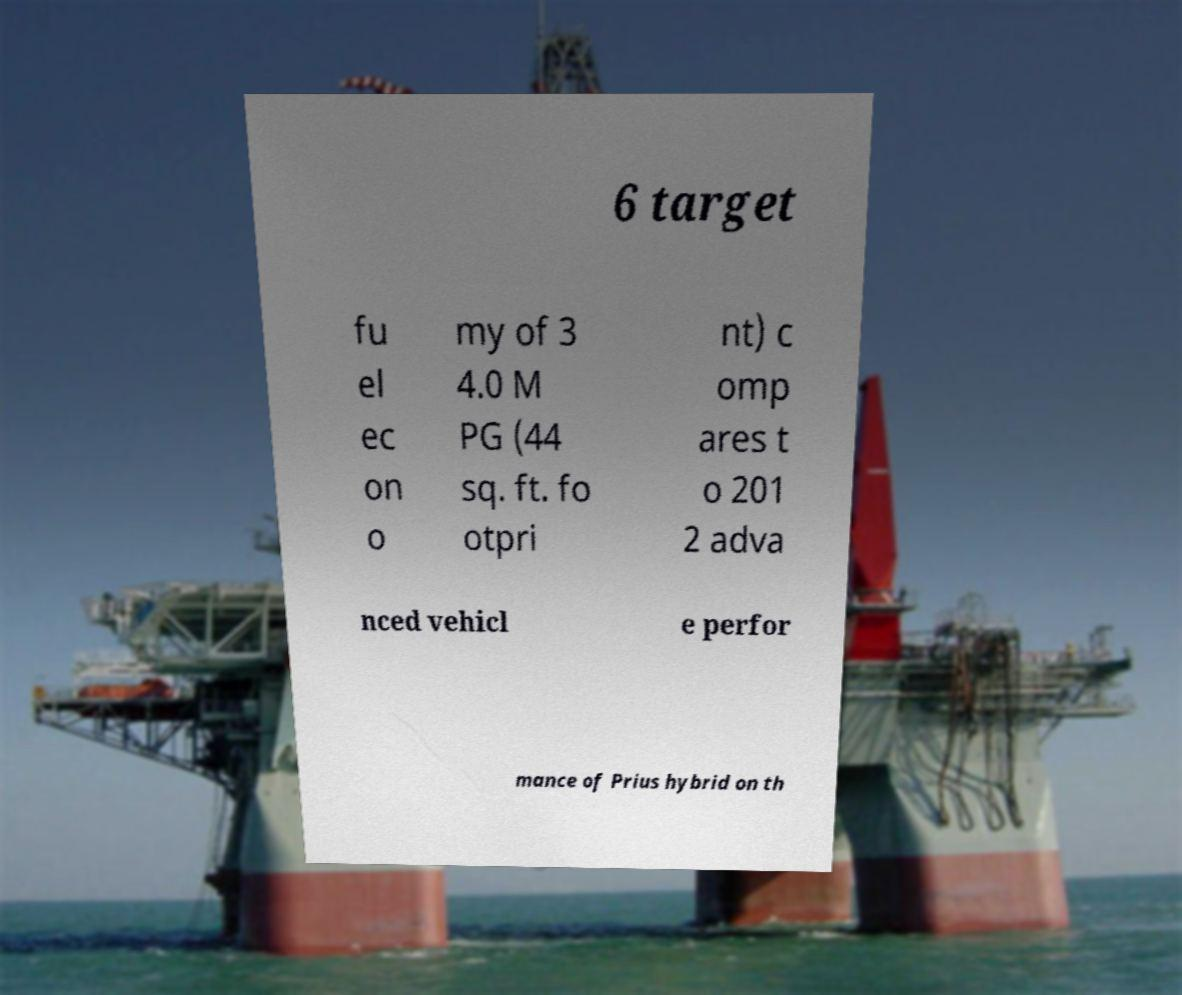I need the written content from this picture converted into text. Can you do that? 6 target fu el ec on o my of 3 4.0 M PG (44 sq. ft. fo otpri nt) c omp ares t o 201 2 adva nced vehicl e perfor mance of Prius hybrid on th 